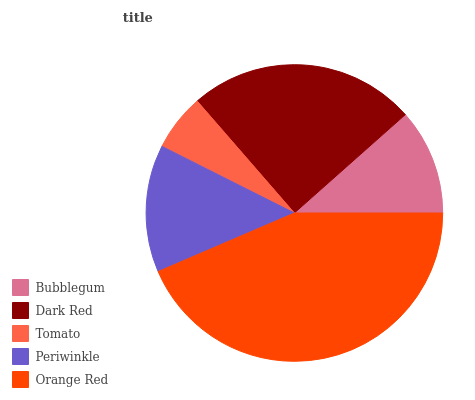Is Tomato the minimum?
Answer yes or no. Yes. Is Orange Red the maximum?
Answer yes or no. Yes. Is Dark Red the minimum?
Answer yes or no. No. Is Dark Red the maximum?
Answer yes or no. No. Is Dark Red greater than Bubblegum?
Answer yes or no. Yes. Is Bubblegum less than Dark Red?
Answer yes or no. Yes. Is Bubblegum greater than Dark Red?
Answer yes or no. No. Is Dark Red less than Bubblegum?
Answer yes or no. No. Is Periwinkle the high median?
Answer yes or no. Yes. Is Periwinkle the low median?
Answer yes or no. Yes. Is Dark Red the high median?
Answer yes or no. No. Is Orange Red the low median?
Answer yes or no. No. 